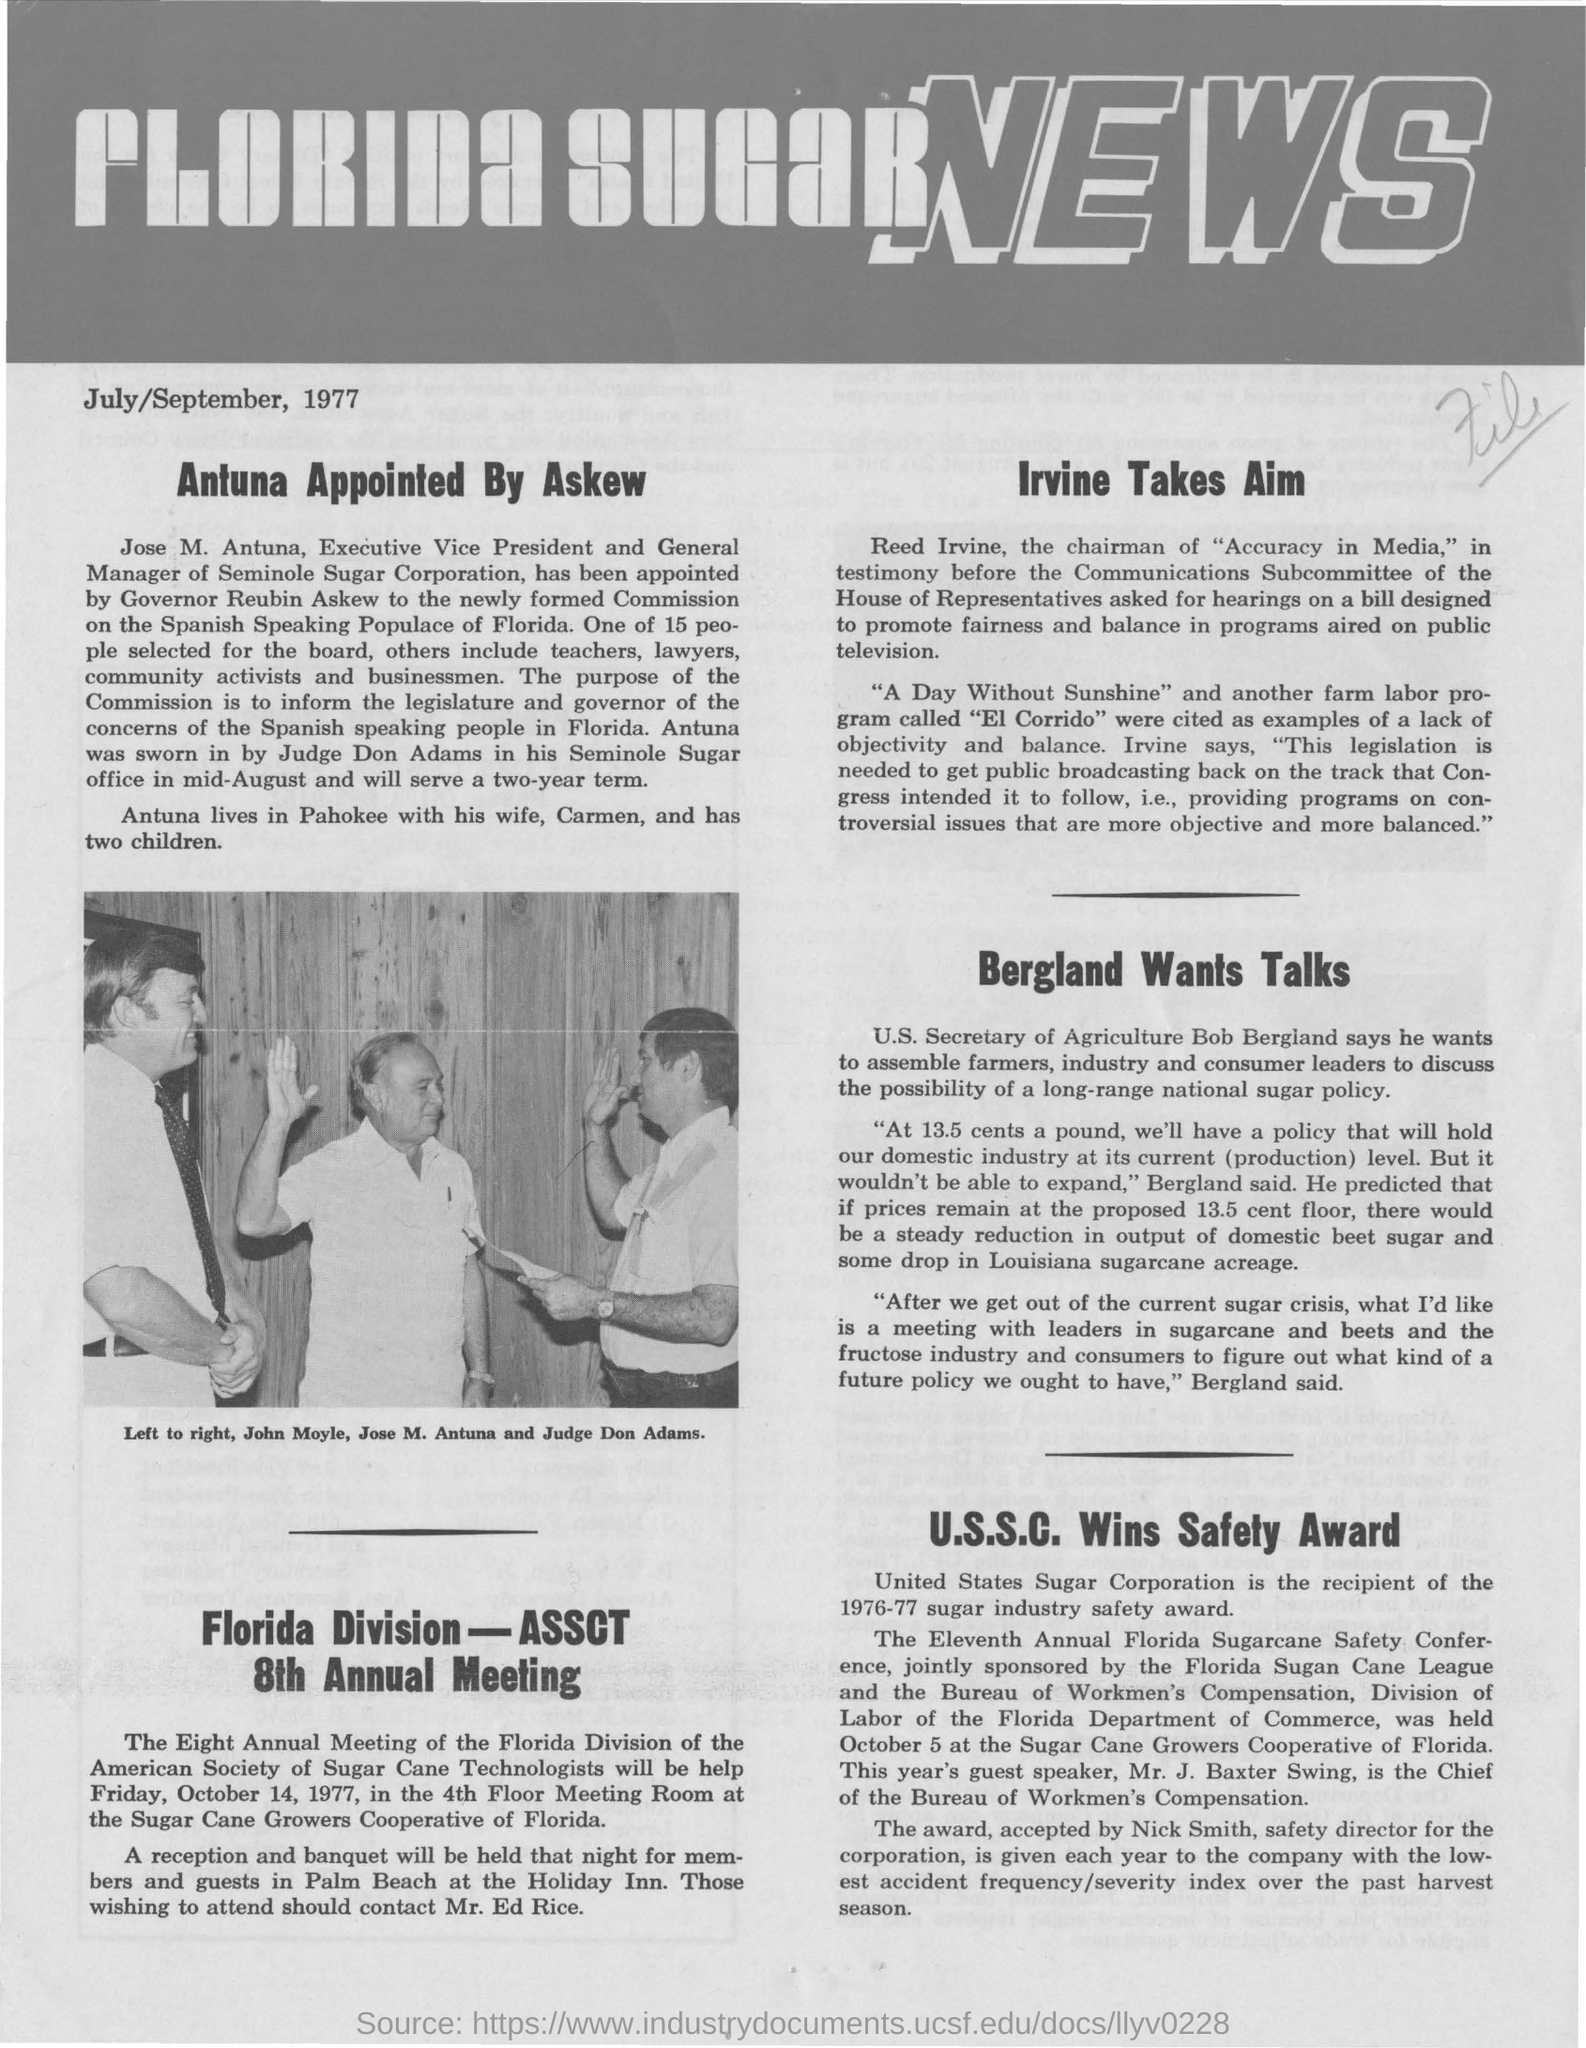Identify some key points in this picture. The heading of the document is "What is the heading of the document? The name of the man standing in the middle of the picture is Jose M. Antuna. The date mentioned is July/September 1977. The Executive Vice President and General Manager of Seminole Sugar Corporation is Jose M. Antuna. 